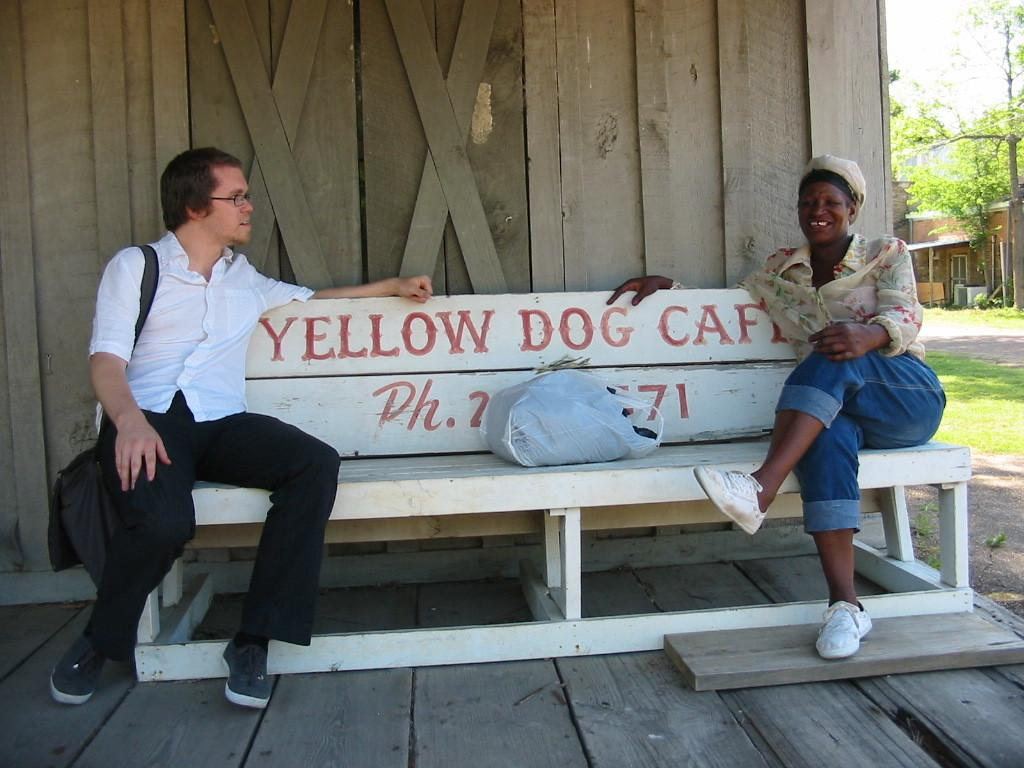How many people are sitting on the bench in the image? There are two persons sitting on a bench in the image. Can you describe what one of the persons is wearing? One person is wearing a bag. What can be seen in the background of the image? There is a tree, grass, and a house in the background. What is covering the bench? There is a cover on the bench. What type of bear can be seen interacting with the persons on the bench in the image? There is no bear present in the image; it only features two persons sitting on a bench. Who is the manager of the house in the background of the image? There is no information about a manager or the house's ownership in the image. 